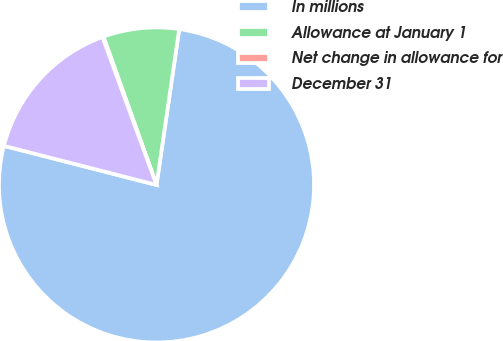Convert chart. <chart><loc_0><loc_0><loc_500><loc_500><pie_chart><fcel>In millions<fcel>Allowance at January 1<fcel>Net change in allowance for<fcel>December 31<nl><fcel>76.69%<fcel>7.77%<fcel>0.11%<fcel>15.43%<nl></chart> 